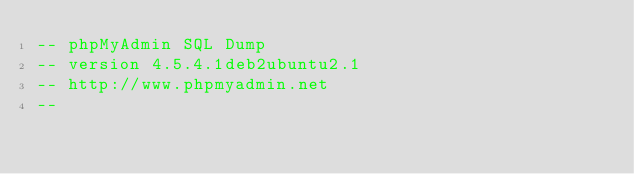<code> <loc_0><loc_0><loc_500><loc_500><_SQL_>-- phpMyAdmin SQL Dump
-- version 4.5.4.1deb2ubuntu2.1
-- http://www.phpmyadmin.net
--</code> 